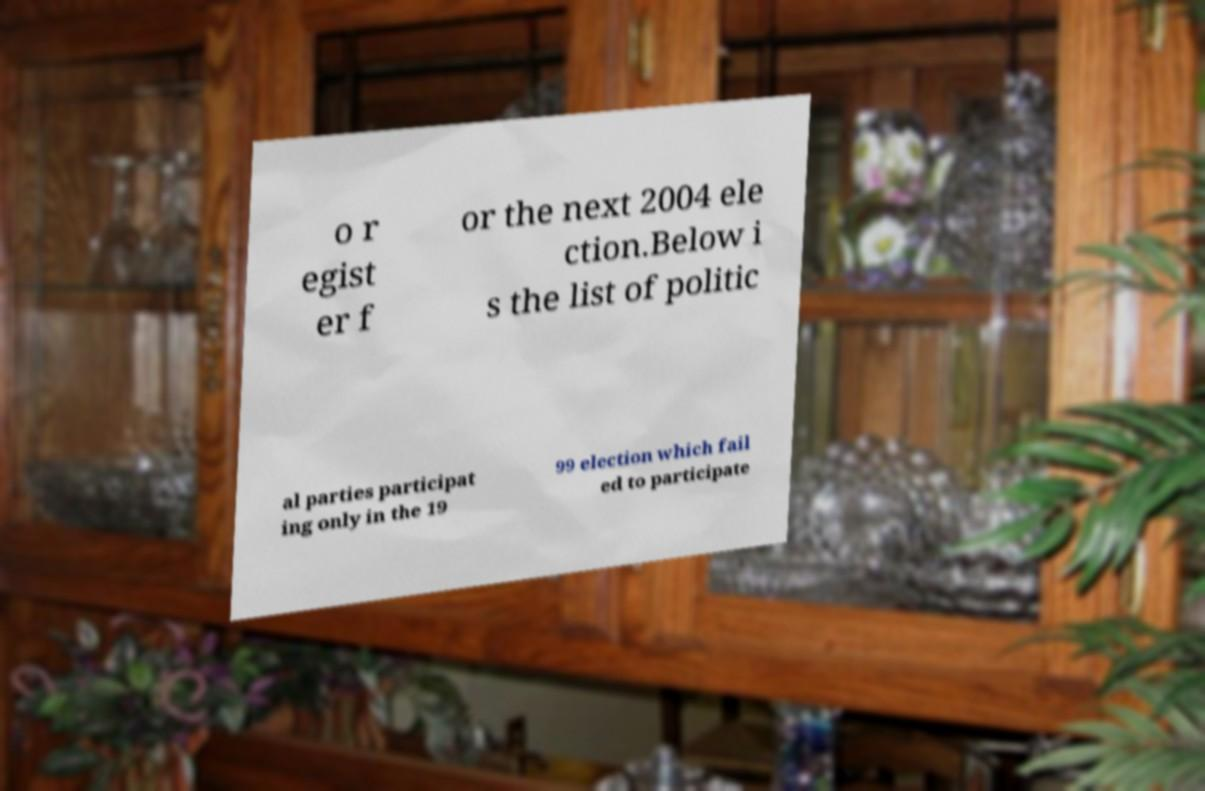Can you read and provide the text displayed in the image?This photo seems to have some interesting text. Can you extract and type it out for me? o r egist er f or the next 2004 ele ction.Below i s the list of politic al parties participat ing only in the 19 99 election which fail ed to participate 